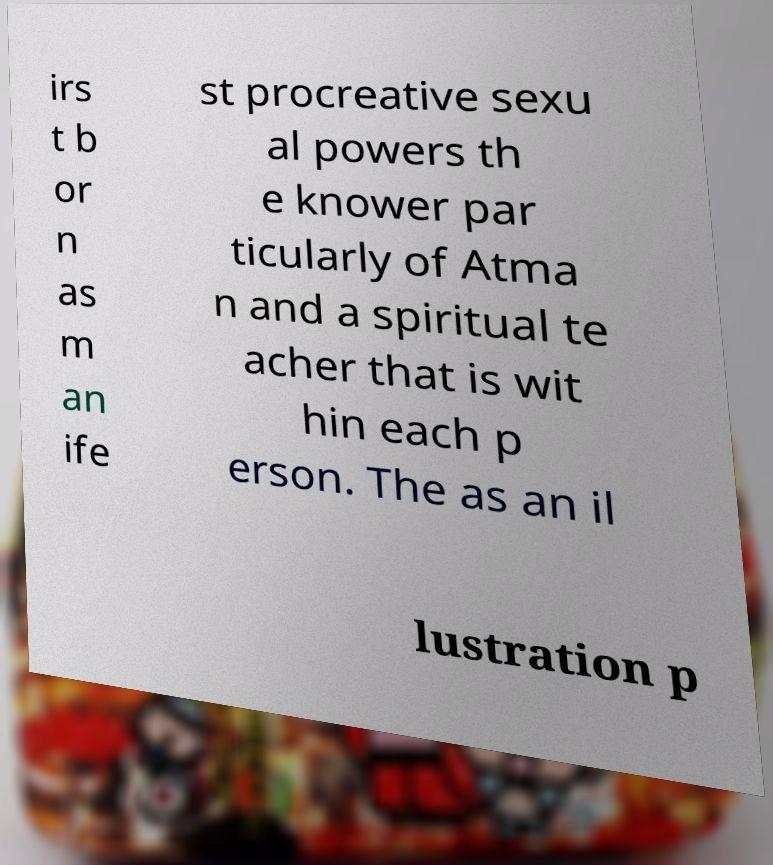For documentation purposes, I need the text within this image transcribed. Could you provide that? irs t b or n as m an ife st procreative sexu al powers th e knower par ticularly of Atma n and a spiritual te acher that is wit hin each p erson. The as an il lustration p 